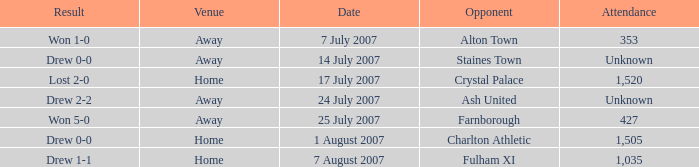Name the venue for staines town Away. 